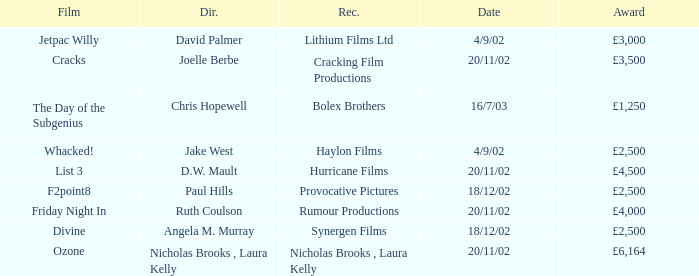What award did the film Ozone win? £6,164. 